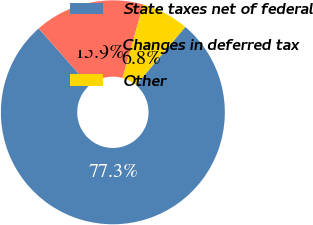Convert chart to OTSL. <chart><loc_0><loc_0><loc_500><loc_500><pie_chart><fcel>State taxes net of federal<fcel>Changes in deferred tax<fcel>Other<nl><fcel>77.27%<fcel>15.91%<fcel>6.82%<nl></chart> 